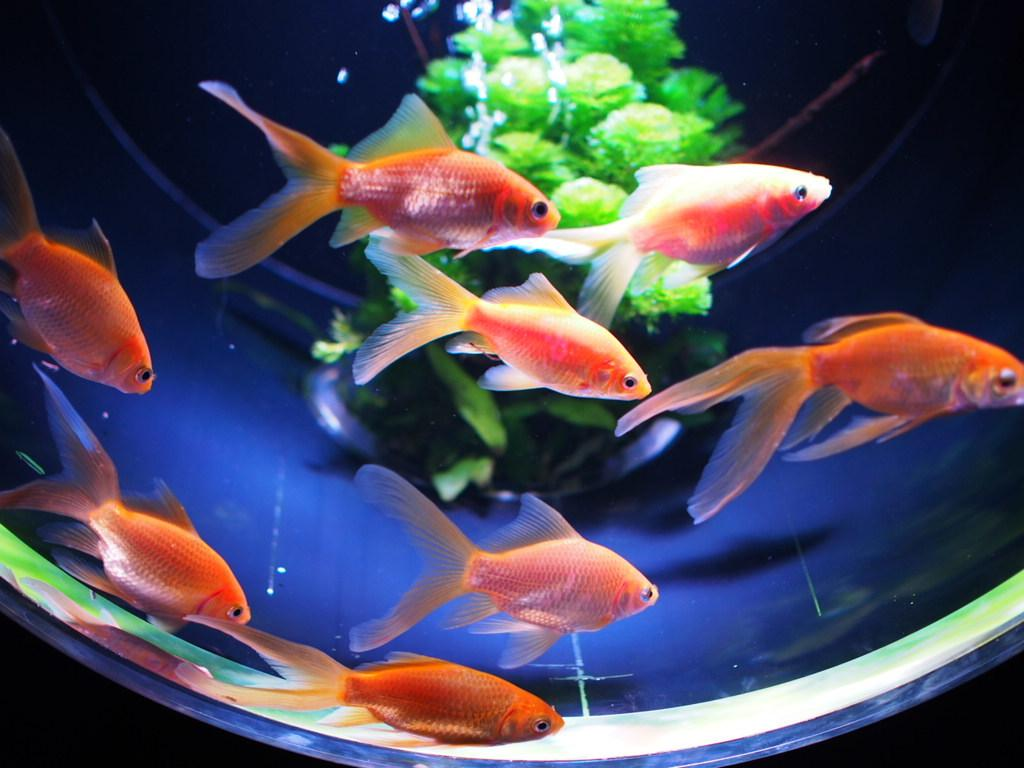What is in the bowl that is visible in the image? The bowl contains water. What else can be seen in the bowl besides water? There are fish and a small plant in the bowl. How many chairs are present in the image? There are no chairs visible in the image. Can you see a star in the image? There is no star present in the image. 